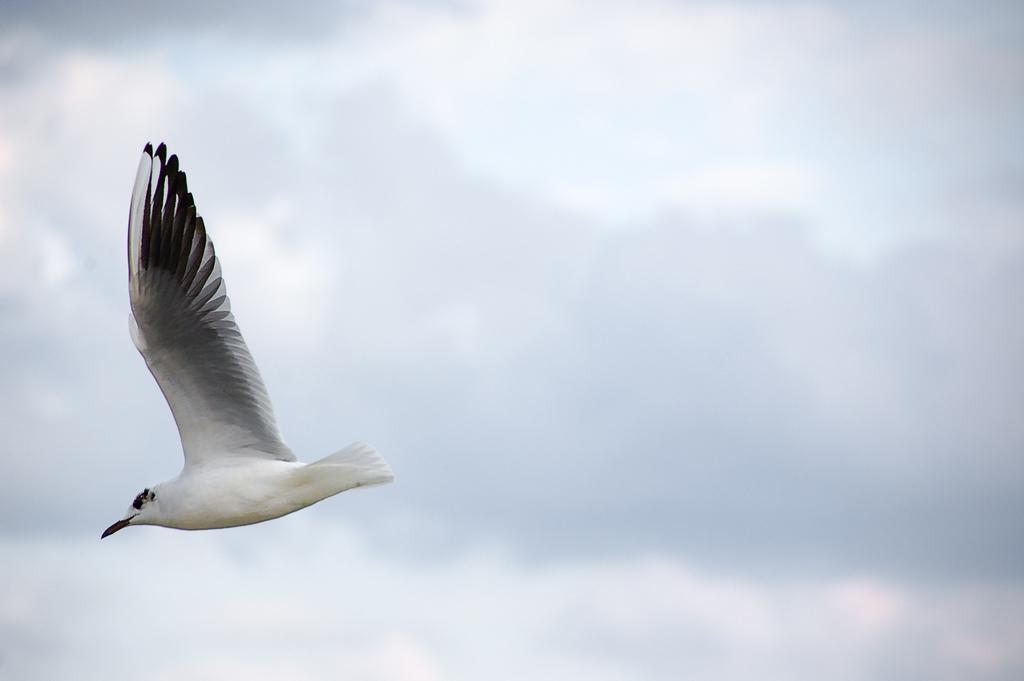What type of animal is in the image? There is a bird in the image. What is the bird doing in the image? The bird is flying in the image. Where is the bird located in the image? The bird is in the sky in the image. What type of apples are being used in the competition in the image? There are no apples present in the image. 